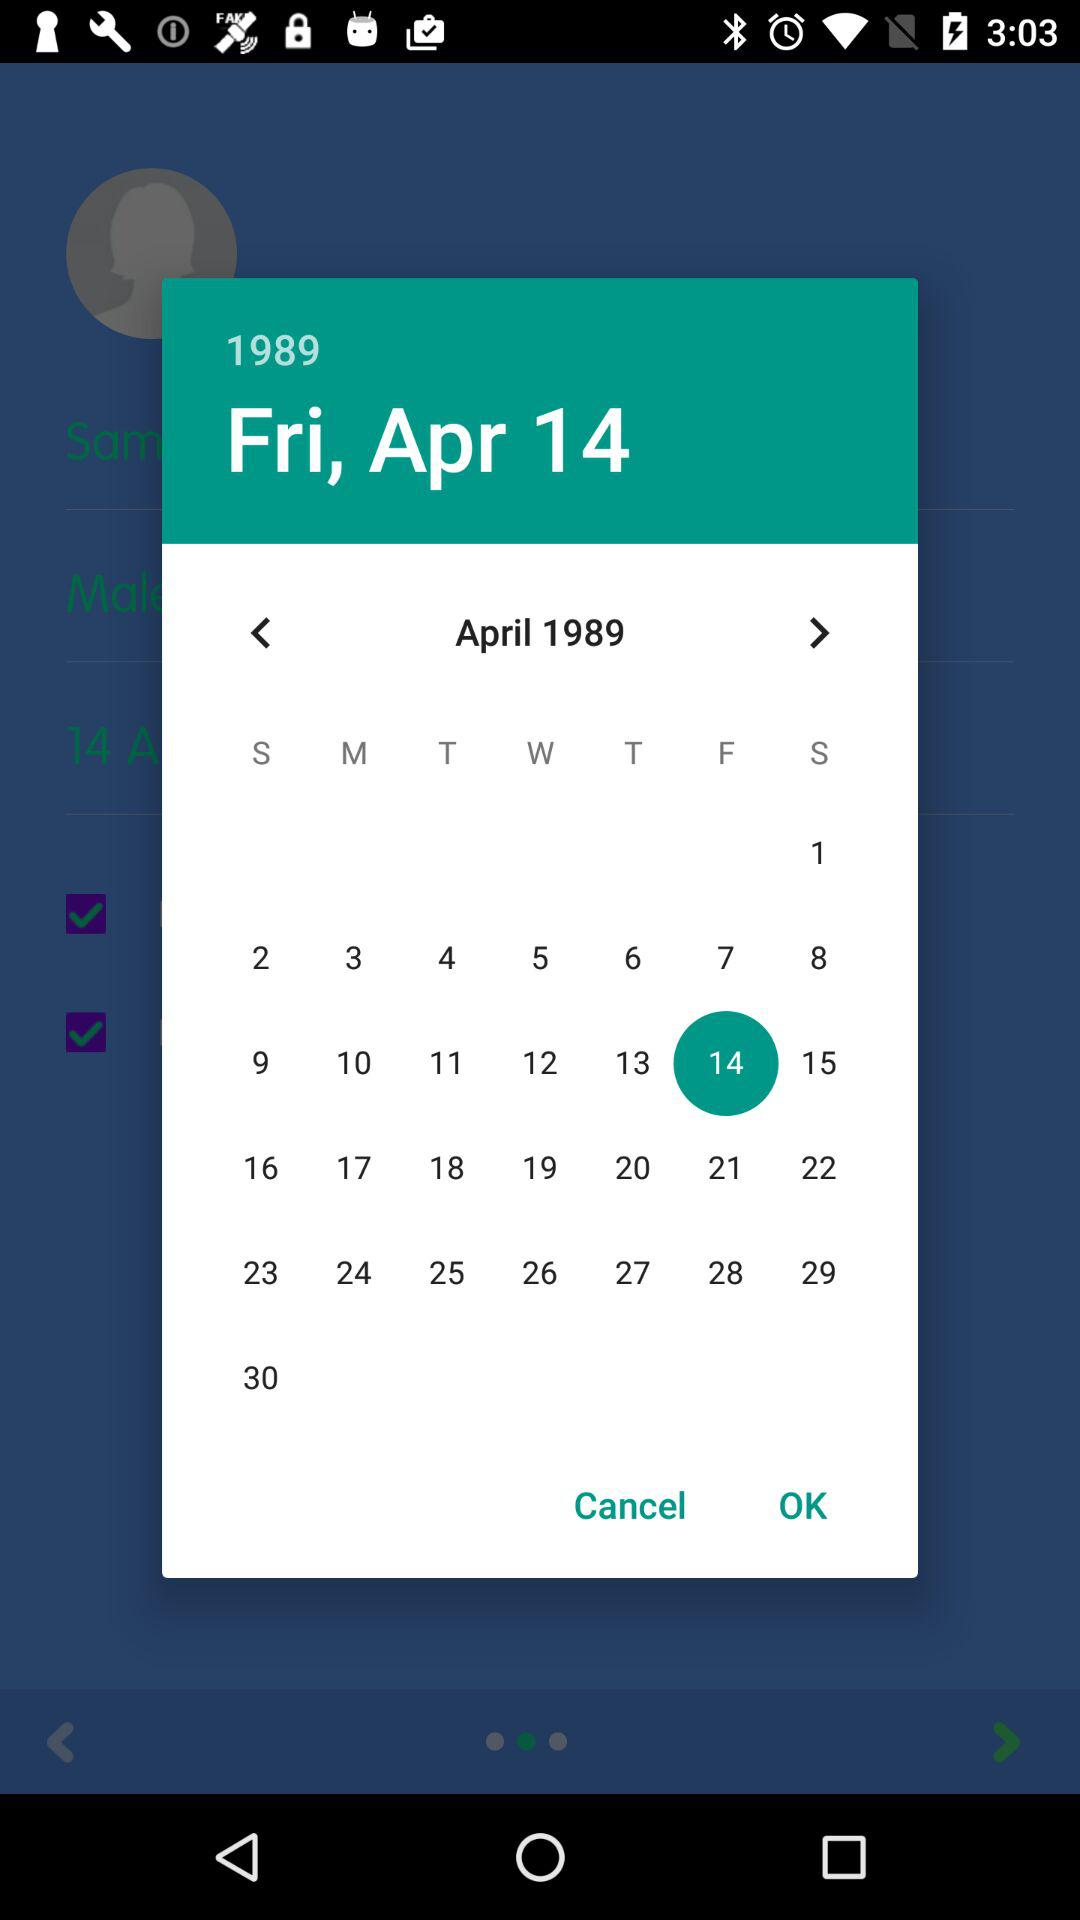What is the selected date? The selected date is Friday, April 14, 1989. 